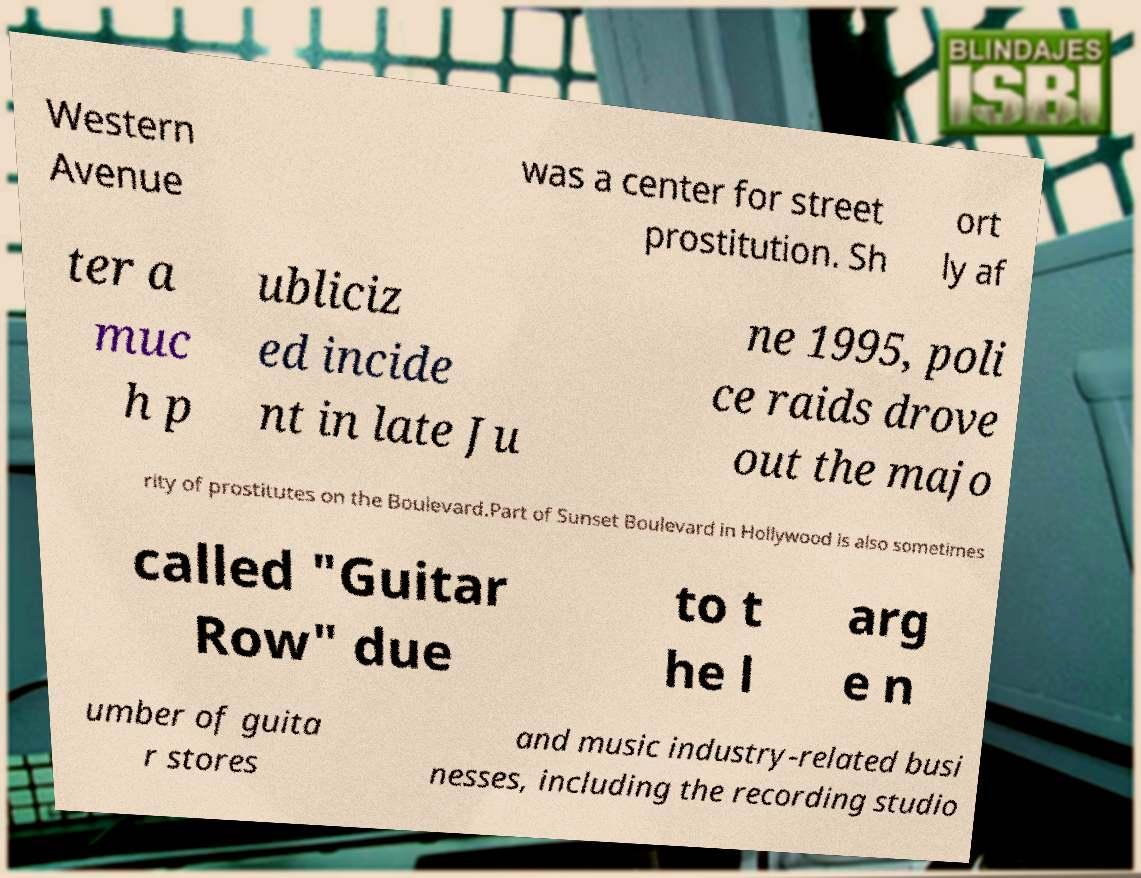Please read and relay the text visible in this image. What does it say? Western Avenue was a center for street prostitution. Sh ort ly af ter a muc h p ubliciz ed incide nt in late Ju ne 1995, poli ce raids drove out the majo rity of prostitutes on the Boulevard.Part of Sunset Boulevard in Hollywood is also sometimes called "Guitar Row" due to t he l arg e n umber of guita r stores and music industry-related busi nesses, including the recording studio 